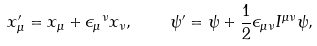<formula> <loc_0><loc_0><loc_500><loc_500>x ^ { \prime } _ { \mu } = x _ { \mu } + { \epsilon _ { \mu } } ^ { \nu } x _ { \nu } , \quad \psi ^ { \prime } = \psi + \frac { 1 } { 2 } \epsilon _ { \mu \nu } I ^ { \mu \nu } \psi ,</formula> 